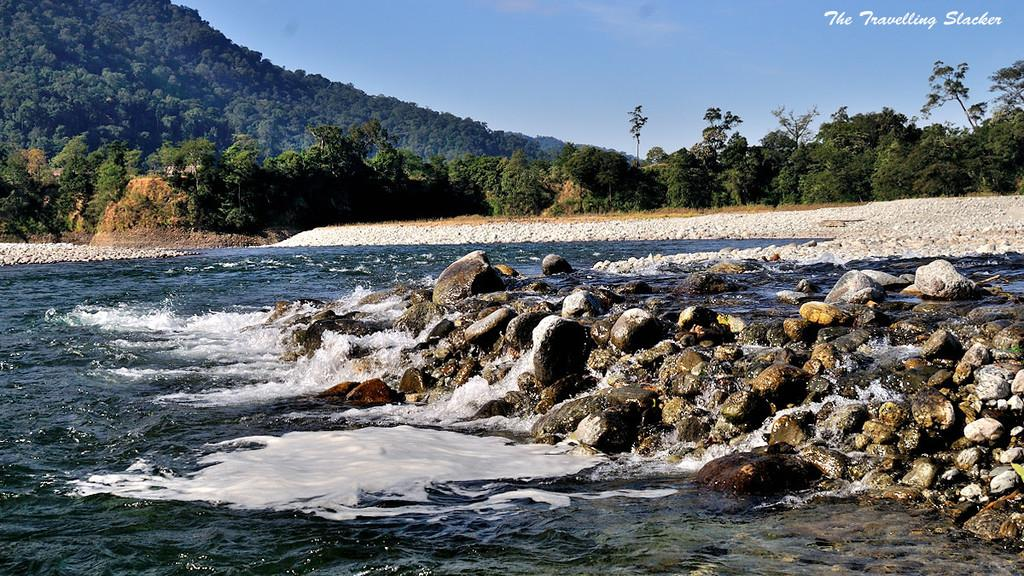What is the primary element in the image? There is water in the image. What other objects or features can be seen in the image? There are rocks and trees in the image. What can be seen in the background of the image? The sky is visible in the background of the image. Is there any text or marking in the image? Yes, there is a watermark in the top right corner of the image. How many rings are visible on the trees in the image? There are no rings visible on the trees in the image; the focus is on the water, rocks, trees, sky, and watermark. 